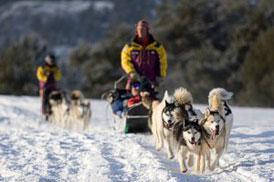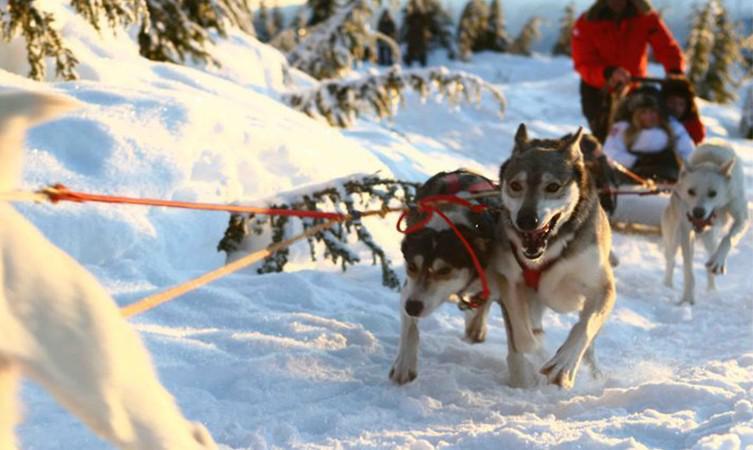The first image is the image on the left, the second image is the image on the right. For the images displayed, is the sentence "In one image, the sled driver wears a bright red jacket." factually correct? Answer yes or no. Yes. The first image is the image on the left, the second image is the image on the right. Assess this claim about the two images: "One image shows one dog sled team being led by a man in a red jacket.". Correct or not? Answer yes or no. Yes. The first image is the image on the left, the second image is the image on the right. For the images displayed, is the sentence "The right image has a man on a sled with a red jacket" factually correct? Answer yes or no. Yes. The first image is the image on the left, the second image is the image on the right. For the images displayed, is the sentence "There is a person in a red coat in the image on the right." factually correct? Answer yes or no. Yes. 